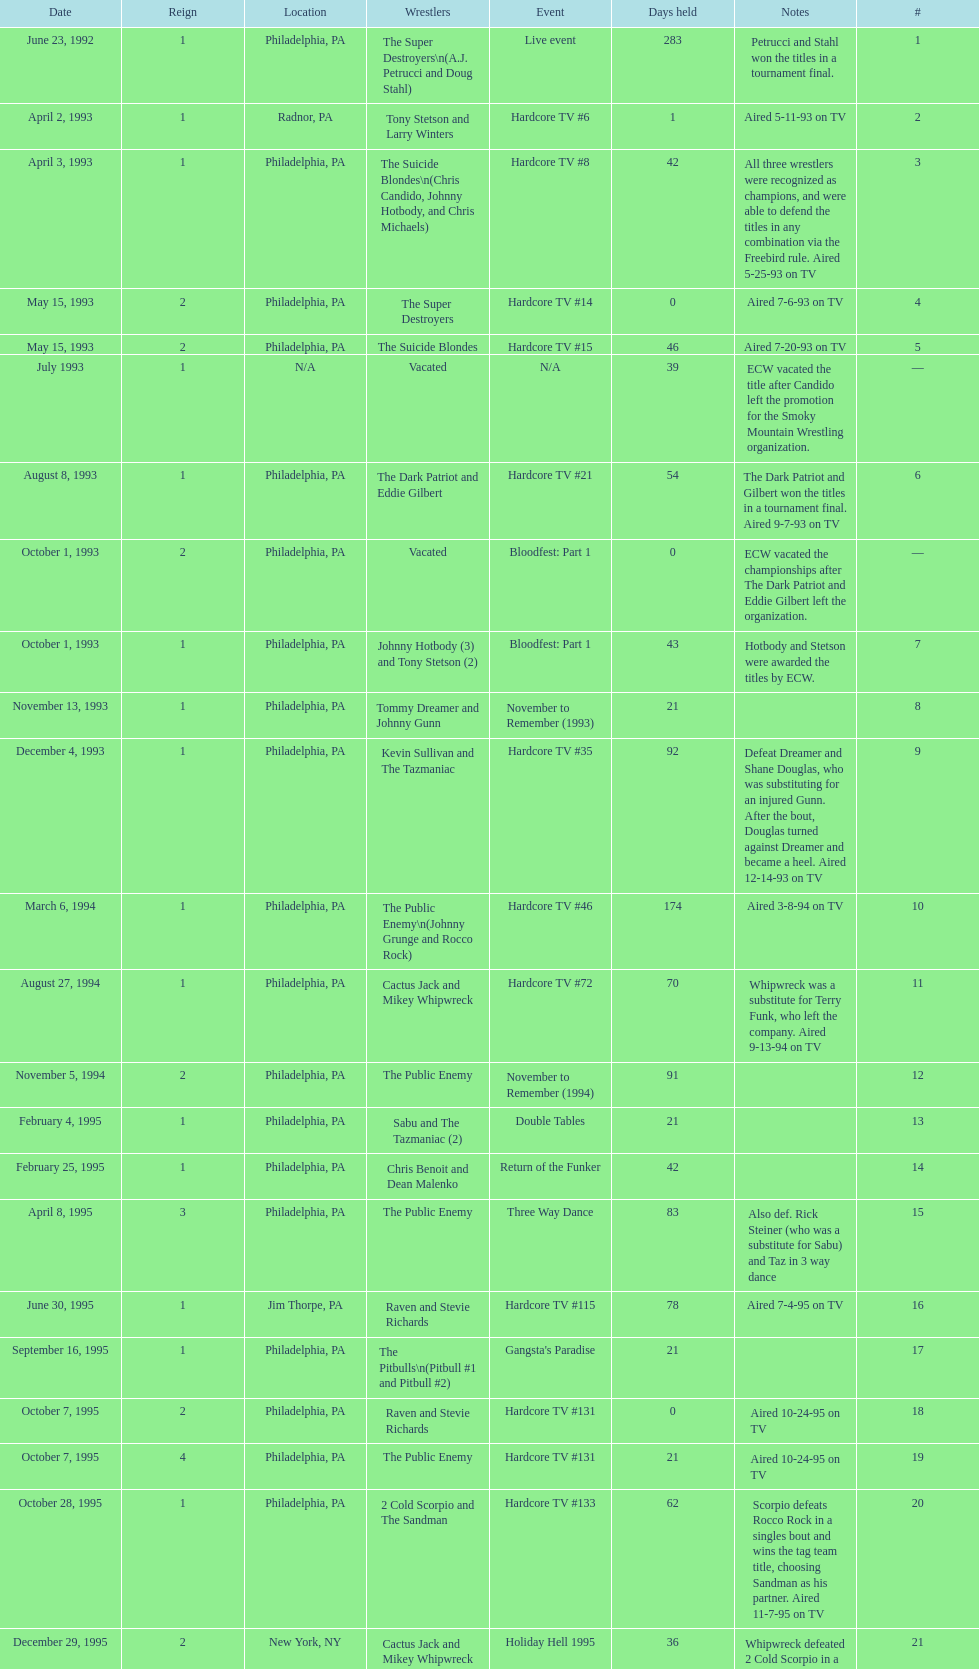How many days did hardcore tv #6 take? 1. 